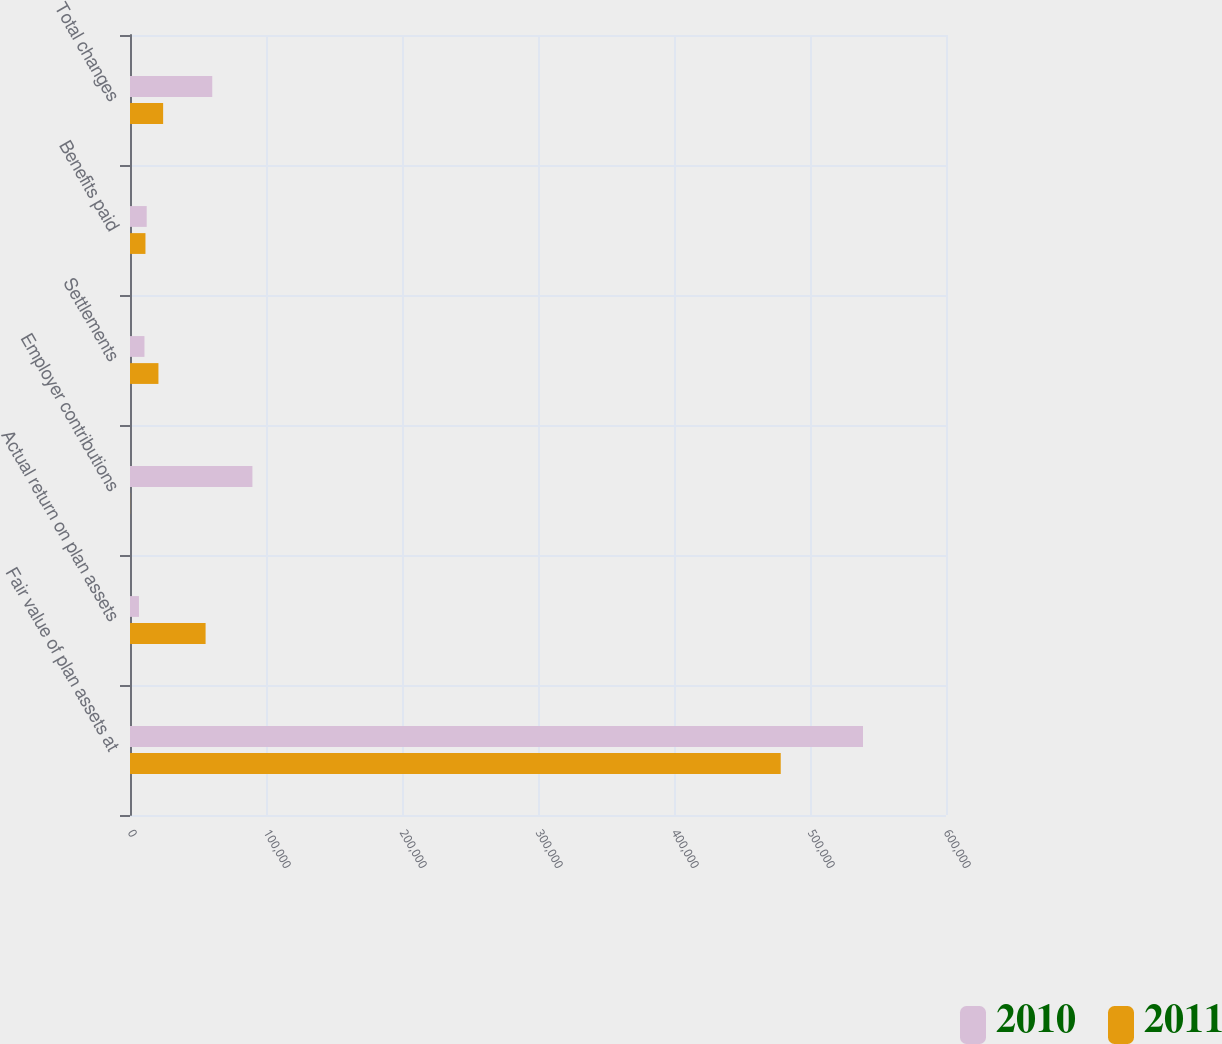Convert chart. <chart><loc_0><loc_0><loc_500><loc_500><stacked_bar_chart><ecel><fcel>Fair value of plan assets at<fcel>Actual return on plan assets<fcel>Employer contributions<fcel>Settlements<fcel>Benefits paid<fcel>Total changes<nl><fcel>2010<fcel>538970<fcel>6593<fcel>90000<fcel>10631<fcel>12285<fcel>60491<nl><fcel>2011<fcel>478479<fcel>55583<fcel>79<fcel>20911<fcel>11367<fcel>24365<nl></chart> 